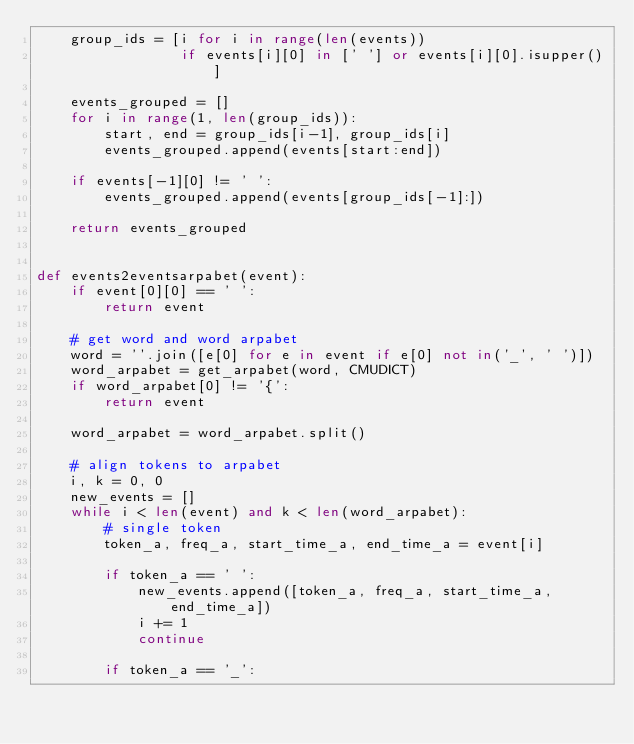Convert code to text. <code><loc_0><loc_0><loc_500><loc_500><_Python_>    group_ids = [i for i in range(len(events))
                 if events[i][0] in [' '] or events[i][0].isupper()]

    events_grouped = []
    for i in range(1, len(group_ids)):
        start, end = group_ids[i-1], group_ids[i]
        events_grouped.append(events[start:end])

    if events[-1][0] != ' ':
        events_grouped.append(events[group_ids[-1]:])

    return events_grouped


def events2eventsarpabet(event):
    if event[0][0] == ' ':
        return event

    # get word and word arpabet
    word = ''.join([e[0] for e in event if e[0] not in('_', ' ')])
    word_arpabet = get_arpabet(word, CMUDICT)
    if word_arpabet[0] != '{':
        return event

    word_arpabet = word_arpabet.split()

    # align tokens to arpabet
    i, k = 0, 0
    new_events = []
    while i < len(event) and k < len(word_arpabet):
        # single token
        token_a, freq_a, start_time_a, end_time_a = event[i]

        if token_a == ' ':
            new_events.append([token_a, freq_a, start_time_a, end_time_a])
            i += 1
            continue

        if token_a == '_':</code> 